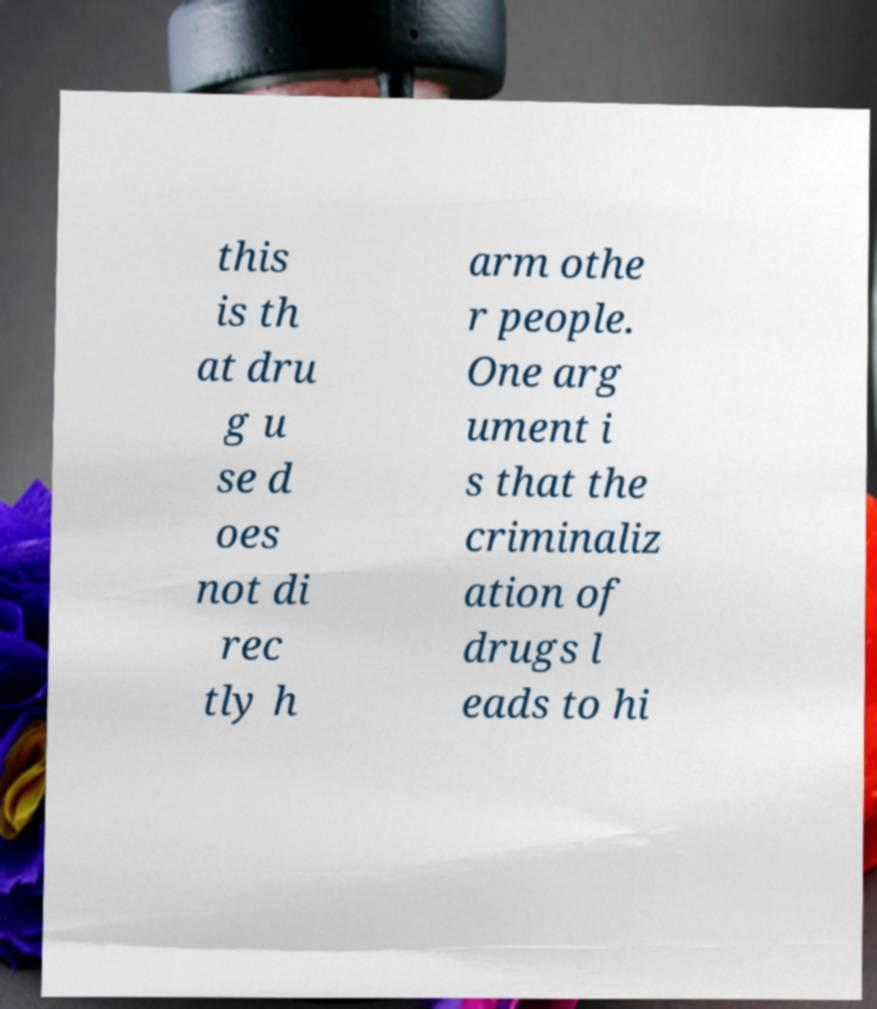Could you assist in decoding the text presented in this image and type it out clearly? this is th at dru g u se d oes not di rec tly h arm othe r people. One arg ument i s that the criminaliz ation of drugs l eads to hi 